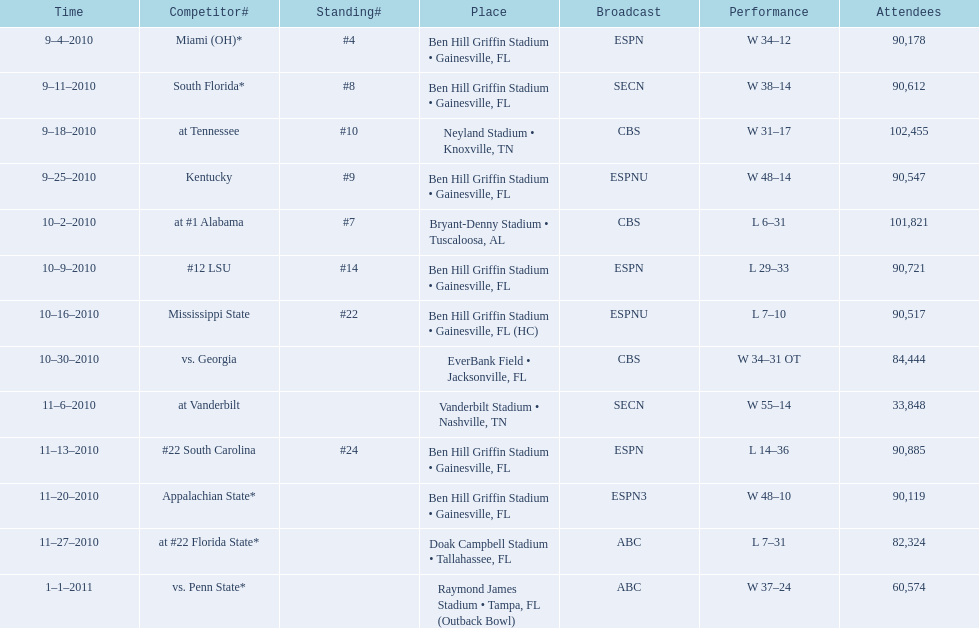What is the number of games played in teh 2010-2011 season 13. 